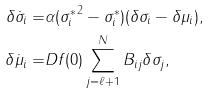<formula> <loc_0><loc_0><loc_500><loc_500>\delta \dot { \sigma } _ { i } = & \alpha ( { \sigma _ { i } ^ { * } } ^ { 2 } - \sigma _ { i } ^ { * } ) ( \delta \sigma _ { i } - \delta \mu _ { i } ) , \\ \delta \dot { \mu } _ { i } = & D f ( 0 ) \sum _ { j = \ell + 1 } ^ { N } B _ { i j } \delta \sigma _ { j } ,</formula> 